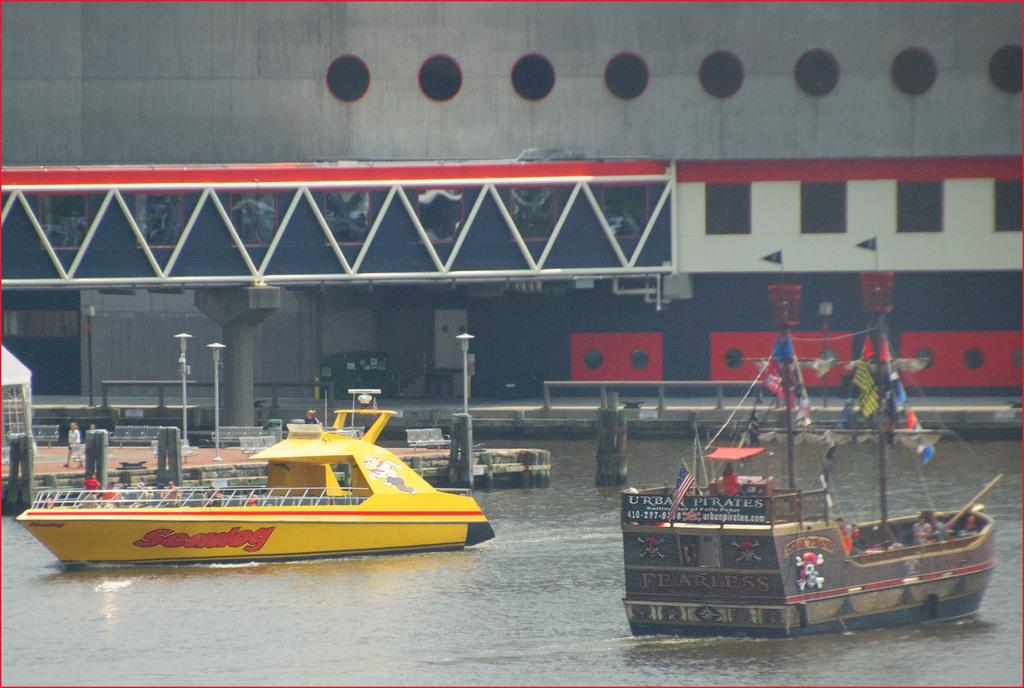What type of body of water is in the image? There is a lake in the image. What is on the lake? Ships are present on the lake. Can you see any people in the image? Yes, there is a person visible in the image. What else can be seen near the lake? There is a building visible beside the lake. What is in the middle of the image? There is a pole visible in the middle of the image. What type of stew is being cooked on the pole in the image? There is no stew or cooking activity present in the image; the pole is simply a stationary object. 